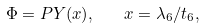Convert formula to latex. <formula><loc_0><loc_0><loc_500><loc_500>\Phi = P Y ( x ) , \quad x = \lambda _ { 6 } / t _ { 6 } ,</formula> 